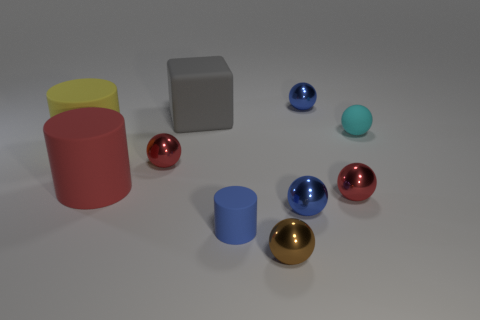There is a red thing that is the same shape as the blue matte thing; what is its material?
Give a very brief answer. Rubber. What is the size of the gray thing that is the same material as the big red object?
Ensure brevity in your answer.  Large. Do the tiny cyan thing that is right of the small brown metallic thing and the tiny metallic thing that is behind the big cube have the same shape?
Ensure brevity in your answer.  Yes. There is a small ball that is the same material as the block; what is its color?
Give a very brief answer. Cyan. There is a sphere that is behind the big gray block; is it the same size as the blue sphere that is in front of the large yellow cylinder?
Provide a short and direct response. Yes. The rubber object that is both left of the small blue matte cylinder and behind the large yellow cylinder has what shape?
Your answer should be compact. Cube. Are there any large yellow things that have the same material as the tiny cylinder?
Offer a very short reply. Yes. Does the small blue sphere behind the yellow rubber cylinder have the same material as the small red sphere on the right side of the blue cylinder?
Ensure brevity in your answer.  Yes. Is the number of tiny blue matte spheres greater than the number of red things?
Make the answer very short. No. There is a small rubber object in front of the red shiny object right of the blue metallic thing that is behind the big yellow matte cylinder; what is its color?
Your answer should be compact. Blue. 